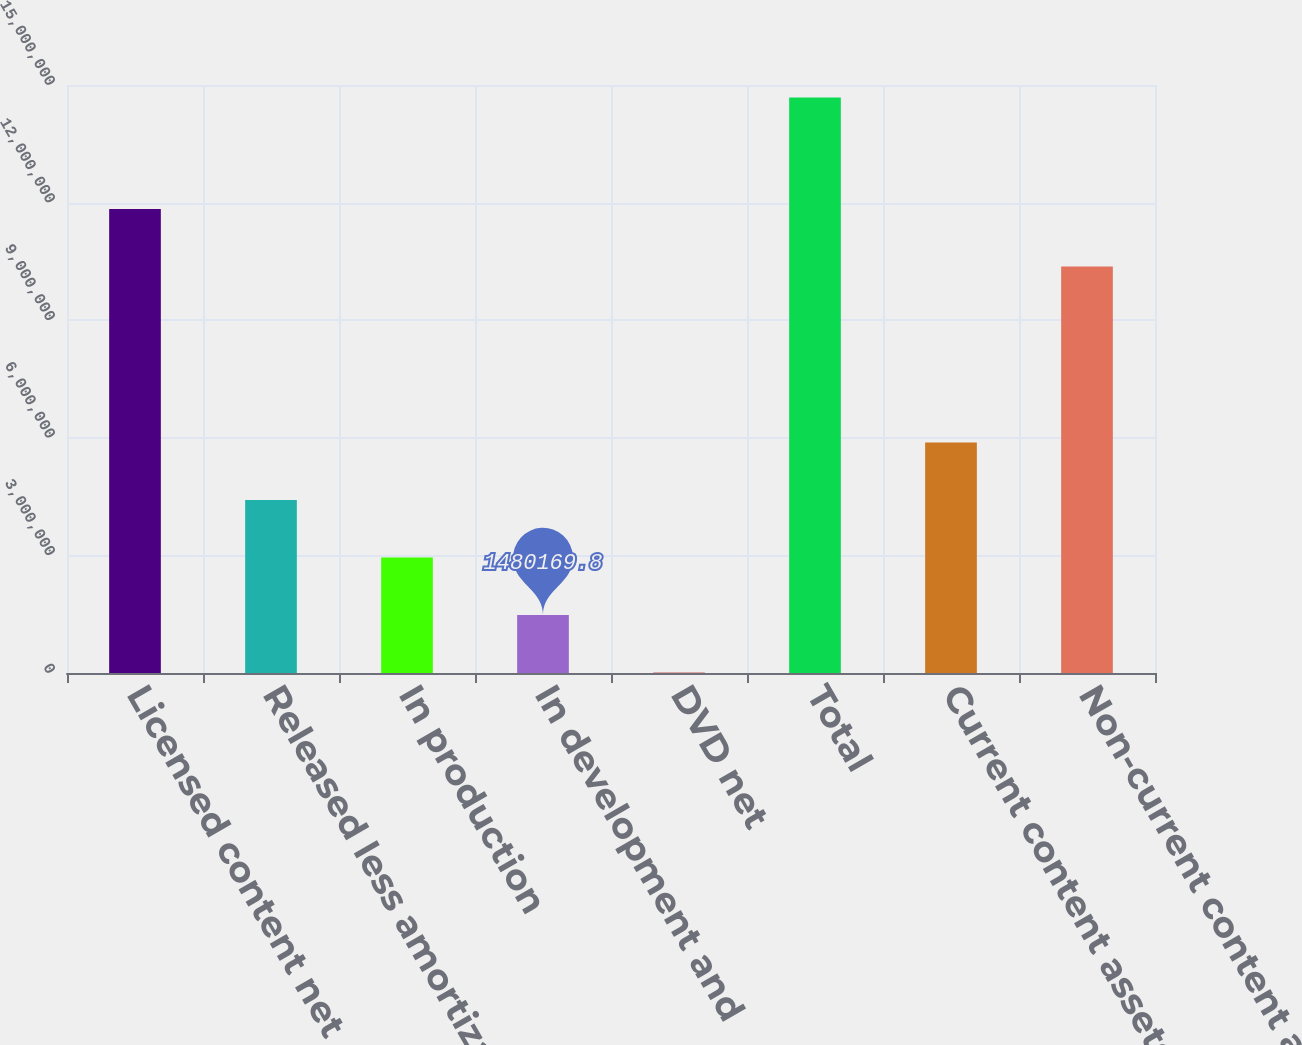Convert chart to OTSL. <chart><loc_0><loc_0><loc_500><loc_500><bar_chart><fcel>Licensed content net<fcel>Released less amortization<fcel>In production<fcel>In development and<fcel>DVD net<fcel>Total<fcel>Current content assets net<fcel>Non-current content assets net<nl><fcel>1.18379e+07<fcel>4.41391e+06<fcel>2.94704e+06<fcel>1.48017e+06<fcel>13301<fcel>1.4682e+07<fcel>5.88078e+06<fcel>1.03711e+07<nl></chart> 